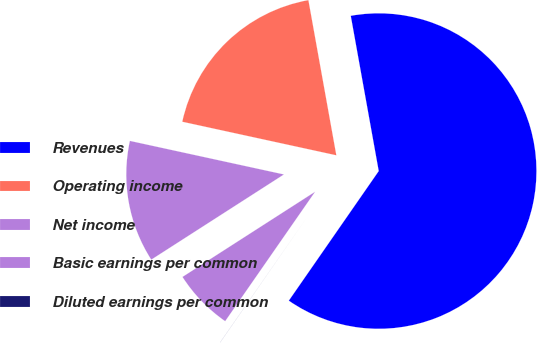Convert chart to OTSL. <chart><loc_0><loc_0><loc_500><loc_500><pie_chart><fcel>Revenues<fcel>Operating income<fcel>Net income<fcel>Basic earnings per common<fcel>Diluted earnings per common<nl><fcel>62.49%<fcel>18.75%<fcel>12.5%<fcel>6.25%<fcel>0.01%<nl></chart> 